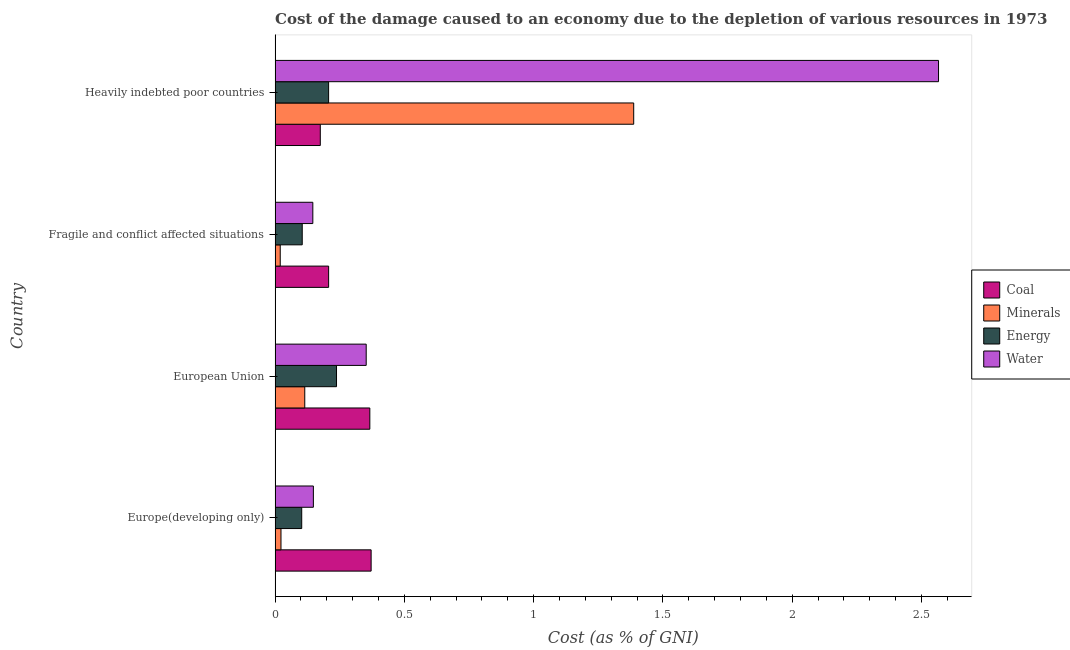How many bars are there on the 2nd tick from the top?
Keep it short and to the point. 4. How many bars are there on the 2nd tick from the bottom?
Your response must be concise. 4. What is the cost of damage due to depletion of energy in Fragile and conflict affected situations?
Provide a short and direct response. 0.11. Across all countries, what is the maximum cost of damage due to depletion of water?
Ensure brevity in your answer.  2.57. Across all countries, what is the minimum cost of damage due to depletion of energy?
Keep it short and to the point. 0.1. In which country was the cost of damage due to depletion of coal maximum?
Ensure brevity in your answer.  Europe(developing only). In which country was the cost of damage due to depletion of coal minimum?
Your answer should be very brief. Heavily indebted poor countries. What is the total cost of damage due to depletion of coal in the graph?
Offer a very short reply. 1.12. What is the difference between the cost of damage due to depletion of minerals in Europe(developing only) and that in Heavily indebted poor countries?
Offer a terse response. -1.36. What is the difference between the cost of damage due to depletion of water in Fragile and conflict affected situations and the cost of damage due to depletion of coal in European Union?
Keep it short and to the point. -0.22. What is the average cost of damage due to depletion of energy per country?
Offer a terse response. 0.16. What is the difference between the cost of damage due to depletion of coal and cost of damage due to depletion of minerals in Fragile and conflict affected situations?
Your answer should be very brief. 0.19. What is the ratio of the cost of damage due to depletion of energy in Fragile and conflict affected situations to that in Heavily indebted poor countries?
Your answer should be compact. 0.51. Is the cost of damage due to depletion of energy in Europe(developing only) less than that in Heavily indebted poor countries?
Your answer should be very brief. Yes. What is the difference between the highest and the second highest cost of damage due to depletion of water?
Offer a very short reply. 2.21. What is the difference between the highest and the lowest cost of damage due to depletion of coal?
Your response must be concise. 0.2. In how many countries, is the cost of damage due to depletion of energy greater than the average cost of damage due to depletion of energy taken over all countries?
Your answer should be compact. 2. Is the sum of the cost of damage due to depletion of minerals in European Union and Fragile and conflict affected situations greater than the maximum cost of damage due to depletion of water across all countries?
Your answer should be compact. No. What does the 1st bar from the top in European Union represents?
Offer a terse response. Water. What does the 2nd bar from the bottom in Europe(developing only) represents?
Offer a terse response. Minerals. Is it the case that in every country, the sum of the cost of damage due to depletion of coal and cost of damage due to depletion of minerals is greater than the cost of damage due to depletion of energy?
Make the answer very short. Yes. How many bars are there?
Ensure brevity in your answer.  16. How many countries are there in the graph?
Offer a terse response. 4. What is the difference between two consecutive major ticks on the X-axis?
Offer a terse response. 0.5. Are the values on the major ticks of X-axis written in scientific E-notation?
Your answer should be compact. No. Where does the legend appear in the graph?
Give a very brief answer. Center right. How are the legend labels stacked?
Your answer should be very brief. Vertical. What is the title of the graph?
Offer a very short reply. Cost of the damage caused to an economy due to the depletion of various resources in 1973 . What is the label or title of the X-axis?
Make the answer very short. Cost (as % of GNI). What is the Cost (as % of GNI) of Coal in Europe(developing only)?
Offer a terse response. 0.37. What is the Cost (as % of GNI) of Minerals in Europe(developing only)?
Your response must be concise. 0.02. What is the Cost (as % of GNI) of Energy in Europe(developing only)?
Your response must be concise. 0.1. What is the Cost (as % of GNI) in Water in Europe(developing only)?
Provide a succinct answer. 0.15. What is the Cost (as % of GNI) of Coal in European Union?
Make the answer very short. 0.37. What is the Cost (as % of GNI) of Minerals in European Union?
Keep it short and to the point. 0.11. What is the Cost (as % of GNI) in Energy in European Union?
Your answer should be compact. 0.24. What is the Cost (as % of GNI) in Water in European Union?
Offer a terse response. 0.35. What is the Cost (as % of GNI) in Coal in Fragile and conflict affected situations?
Offer a very short reply. 0.21. What is the Cost (as % of GNI) in Minerals in Fragile and conflict affected situations?
Provide a succinct answer. 0.02. What is the Cost (as % of GNI) of Energy in Fragile and conflict affected situations?
Give a very brief answer. 0.11. What is the Cost (as % of GNI) in Water in Fragile and conflict affected situations?
Your answer should be compact. 0.15. What is the Cost (as % of GNI) in Coal in Heavily indebted poor countries?
Provide a short and direct response. 0.17. What is the Cost (as % of GNI) of Minerals in Heavily indebted poor countries?
Provide a short and direct response. 1.39. What is the Cost (as % of GNI) of Energy in Heavily indebted poor countries?
Ensure brevity in your answer.  0.21. What is the Cost (as % of GNI) in Water in Heavily indebted poor countries?
Offer a terse response. 2.57. Across all countries, what is the maximum Cost (as % of GNI) in Coal?
Offer a terse response. 0.37. Across all countries, what is the maximum Cost (as % of GNI) in Minerals?
Your answer should be very brief. 1.39. Across all countries, what is the maximum Cost (as % of GNI) of Energy?
Keep it short and to the point. 0.24. Across all countries, what is the maximum Cost (as % of GNI) in Water?
Offer a terse response. 2.57. Across all countries, what is the minimum Cost (as % of GNI) in Coal?
Offer a terse response. 0.17. Across all countries, what is the minimum Cost (as % of GNI) in Minerals?
Your answer should be compact. 0.02. Across all countries, what is the minimum Cost (as % of GNI) of Energy?
Give a very brief answer. 0.1. Across all countries, what is the minimum Cost (as % of GNI) in Water?
Make the answer very short. 0.15. What is the total Cost (as % of GNI) in Coal in the graph?
Keep it short and to the point. 1.12. What is the total Cost (as % of GNI) of Minerals in the graph?
Your answer should be compact. 1.54. What is the total Cost (as % of GNI) of Energy in the graph?
Give a very brief answer. 0.65. What is the total Cost (as % of GNI) in Water in the graph?
Your response must be concise. 3.21. What is the difference between the Cost (as % of GNI) of Coal in Europe(developing only) and that in European Union?
Your response must be concise. 0.01. What is the difference between the Cost (as % of GNI) of Minerals in Europe(developing only) and that in European Union?
Offer a very short reply. -0.09. What is the difference between the Cost (as % of GNI) of Energy in Europe(developing only) and that in European Union?
Your answer should be very brief. -0.13. What is the difference between the Cost (as % of GNI) of Water in Europe(developing only) and that in European Union?
Your answer should be compact. -0.2. What is the difference between the Cost (as % of GNI) in Coal in Europe(developing only) and that in Fragile and conflict affected situations?
Offer a very short reply. 0.16. What is the difference between the Cost (as % of GNI) in Minerals in Europe(developing only) and that in Fragile and conflict affected situations?
Ensure brevity in your answer.  0. What is the difference between the Cost (as % of GNI) in Energy in Europe(developing only) and that in Fragile and conflict affected situations?
Provide a succinct answer. -0. What is the difference between the Cost (as % of GNI) of Water in Europe(developing only) and that in Fragile and conflict affected situations?
Offer a very short reply. 0. What is the difference between the Cost (as % of GNI) of Coal in Europe(developing only) and that in Heavily indebted poor countries?
Offer a very short reply. 0.2. What is the difference between the Cost (as % of GNI) in Minerals in Europe(developing only) and that in Heavily indebted poor countries?
Your answer should be compact. -1.36. What is the difference between the Cost (as % of GNI) of Energy in Europe(developing only) and that in Heavily indebted poor countries?
Make the answer very short. -0.1. What is the difference between the Cost (as % of GNI) in Water in Europe(developing only) and that in Heavily indebted poor countries?
Provide a short and direct response. -2.42. What is the difference between the Cost (as % of GNI) in Coal in European Union and that in Fragile and conflict affected situations?
Offer a very short reply. 0.16. What is the difference between the Cost (as % of GNI) in Minerals in European Union and that in Fragile and conflict affected situations?
Provide a short and direct response. 0.09. What is the difference between the Cost (as % of GNI) of Energy in European Union and that in Fragile and conflict affected situations?
Keep it short and to the point. 0.13. What is the difference between the Cost (as % of GNI) in Water in European Union and that in Fragile and conflict affected situations?
Ensure brevity in your answer.  0.21. What is the difference between the Cost (as % of GNI) of Coal in European Union and that in Heavily indebted poor countries?
Make the answer very short. 0.19. What is the difference between the Cost (as % of GNI) in Minerals in European Union and that in Heavily indebted poor countries?
Your response must be concise. -1.27. What is the difference between the Cost (as % of GNI) in Energy in European Union and that in Heavily indebted poor countries?
Your response must be concise. 0.03. What is the difference between the Cost (as % of GNI) in Water in European Union and that in Heavily indebted poor countries?
Offer a very short reply. -2.21. What is the difference between the Cost (as % of GNI) in Coal in Fragile and conflict affected situations and that in Heavily indebted poor countries?
Offer a very short reply. 0.03. What is the difference between the Cost (as % of GNI) in Minerals in Fragile and conflict affected situations and that in Heavily indebted poor countries?
Offer a very short reply. -1.37. What is the difference between the Cost (as % of GNI) of Energy in Fragile and conflict affected situations and that in Heavily indebted poor countries?
Make the answer very short. -0.1. What is the difference between the Cost (as % of GNI) in Water in Fragile and conflict affected situations and that in Heavily indebted poor countries?
Ensure brevity in your answer.  -2.42. What is the difference between the Cost (as % of GNI) of Coal in Europe(developing only) and the Cost (as % of GNI) of Minerals in European Union?
Your answer should be compact. 0.26. What is the difference between the Cost (as % of GNI) of Coal in Europe(developing only) and the Cost (as % of GNI) of Energy in European Union?
Your response must be concise. 0.13. What is the difference between the Cost (as % of GNI) of Coal in Europe(developing only) and the Cost (as % of GNI) of Water in European Union?
Keep it short and to the point. 0.02. What is the difference between the Cost (as % of GNI) in Minerals in Europe(developing only) and the Cost (as % of GNI) in Energy in European Union?
Keep it short and to the point. -0.21. What is the difference between the Cost (as % of GNI) of Minerals in Europe(developing only) and the Cost (as % of GNI) of Water in European Union?
Offer a terse response. -0.33. What is the difference between the Cost (as % of GNI) in Energy in Europe(developing only) and the Cost (as % of GNI) in Water in European Union?
Provide a succinct answer. -0.25. What is the difference between the Cost (as % of GNI) in Coal in Europe(developing only) and the Cost (as % of GNI) in Minerals in Fragile and conflict affected situations?
Provide a succinct answer. 0.35. What is the difference between the Cost (as % of GNI) in Coal in Europe(developing only) and the Cost (as % of GNI) in Energy in Fragile and conflict affected situations?
Make the answer very short. 0.27. What is the difference between the Cost (as % of GNI) in Coal in Europe(developing only) and the Cost (as % of GNI) in Water in Fragile and conflict affected situations?
Keep it short and to the point. 0.23. What is the difference between the Cost (as % of GNI) of Minerals in Europe(developing only) and the Cost (as % of GNI) of Energy in Fragile and conflict affected situations?
Your answer should be very brief. -0.08. What is the difference between the Cost (as % of GNI) of Minerals in Europe(developing only) and the Cost (as % of GNI) of Water in Fragile and conflict affected situations?
Give a very brief answer. -0.12. What is the difference between the Cost (as % of GNI) in Energy in Europe(developing only) and the Cost (as % of GNI) in Water in Fragile and conflict affected situations?
Keep it short and to the point. -0.04. What is the difference between the Cost (as % of GNI) in Coal in Europe(developing only) and the Cost (as % of GNI) in Minerals in Heavily indebted poor countries?
Your answer should be compact. -1.02. What is the difference between the Cost (as % of GNI) in Coal in Europe(developing only) and the Cost (as % of GNI) in Energy in Heavily indebted poor countries?
Make the answer very short. 0.16. What is the difference between the Cost (as % of GNI) of Coal in Europe(developing only) and the Cost (as % of GNI) of Water in Heavily indebted poor countries?
Make the answer very short. -2.19. What is the difference between the Cost (as % of GNI) of Minerals in Europe(developing only) and the Cost (as % of GNI) of Energy in Heavily indebted poor countries?
Your answer should be compact. -0.18. What is the difference between the Cost (as % of GNI) of Minerals in Europe(developing only) and the Cost (as % of GNI) of Water in Heavily indebted poor countries?
Provide a short and direct response. -2.54. What is the difference between the Cost (as % of GNI) of Energy in Europe(developing only) and the Cost (as % of GNI) of Water in Heavily indebted poor countries?
Give a very brief answer. -2.46. What is the difference between the Cost (as % of GNI) of Coal in European Union and the Cost (as % of GNI) of Minerals in Fragile and conflict affected situations?
Your answer should be very brief. 0.35. What is the difference between the Cost (as % of GNI) of Coal in European Union and the Cost (as % of GNI) of Energy in Fragile and conflict affected situations?
Provide a short and direct response. 0.26. What is the difference between the Cost (as % of GNI) in Coal in European Union and the Cost (as % of GNI) in Water in Fragile and conflict affected situations?
Offer a terse response. 0.22. What is the difference between the Cost (as % of GNI) of Minerals in European Union and the Cost (as % of GNI) of Energy in Fragile and conflict affected situations?
Provide a succinct answer. 0.01. What is the difference between the Cost (as % of GNI) of Minerals in European Union and the Cost (as % of GNI) of Water in Fragile and conflict affected situations?
Keep it short and to the point. -0.03. What is the difference between the Cost (as % of GNI) of Energy in European Union and the Cost (as % of GNI) of Water in Fragile and conflict affected situations?
Your response must be concise. 0.09. What is the difference between the Cost (as % of GNI) in Coal in European Union and the Cost (as % of GNI) in Minerals in Heavily indebted poor countries?
Your response must be concise. -1.02. What is the difference between the Cost (as % of GNI) of Coal in European Union and the Cost (as % of GNI) of Energy in Heavily indebted poor countries?
Your answer should be very brief. 0.16. What is the difference between the Cost (as % of GNI) in Coal in European Union and the Cost (as % of GNI) in Water in Heavily indebted poor countries?
Offer a very short reply. -2.2. What is the difference between the Cost (as % of GNI) in Minerals in European Union and the Cost (as % of GNI) in Energy in Heavily indebted poor countries?
Offer a very short reply. -0.09. What is the difference between the Cost (as % of GNI) of Minerals in European Union and the Cost (as % of GNI) of Water in Heavily indebted poor countries?
Offer a very short reply. -2.45. What is the difference between the Cost (as % of GNI) in Energy in European Union and the Cost (as % of GNI) in Water in Heavily indebted poor countries?
Provide a short and direct response. -2.33. What is the difference between the Cost (as % of GNI) in Coal in Fragile and conflict affected situations and the Cost (as % of GNI) in Minerals in Heavily indebted poor countries?
Keep it short and to the point. -1.18. What is the difference between the Cost (as % of GNI) in Coal in Fragile and conflict affected situations and the Cost (as % of GNI) in Energy in Heavily indebted poor countries?
Make the answer very short. 0. What is the difference between the Cost (as % of GNI) in Coal in Fragile and conflict affected situations and the Cost (as % of GNI) in Water in Heavily indebted poor countries?
Offer a very short reply. -2.36. What is the difference between the Cost (as % of GNI) in Minerals in Fragile and conflict affected situations and the Cost (as % of GNI) in Energy in Heavily indebted poor countries?
Ensure brevity in your answer.  -0.19. What is the difference between the Cost (as % of GNI) in Minerals in Fragile and conflict affected situations and the Cost (as % of GNI) in Water in Heavily indebted poor countries?
Your answer should be compact. -2.55. What is the difference between the Cost (as % of GNI) in Energy in Fragile and conflict affected situations and the Cost (as % of GNI) in Water in Heavily indebted poor countries?
Keep it short and to the point. -2.46. What is the average Cost (as % of GNI) in Coal per country?
Your response must be concise. 0.28. What is the average Cost (as % of GNI) of Minerals per country?
Your response must be concise. 0.39. What is the average Cost (as % of GNI) in Energy per country?
Offer a terse response. 0.16. What is the average Cost (as % of GNI) of Water per country?
Your answer should be very brief. 0.8. What is the difference between the Cost (as % of GNI) of Coal and Cost (as % of GNI) of Minerals in Europe(developing only)?
Keep it short and to the point. 0.35. What is the difference between the Cost (as % of GNI) of Coal and Cost (as % of GNI) of Energy in Europe(developing only)?
Offer a terse response. 0.27. What is the difference between the Cost (as % of GNI) in Coal and Cost (as % of GNI) in Water in Europe(developing only)?
Make the answer very short. 0.22. What is the difference between the Cost (as % of GNI) of Minerals and Cost (as % of GNI) of Energy in Europe(developing only)?
Provide a short and direct response. -0.08. What is the difference between the Cost (as % of GNI) of Minerals and Cost (as % of GNI) of Water in Europe(developing only)?
Your response must be concise. -0.13. What is the difference between the Cost (as % of GNI) of Energy and Cost (as % of GNI) of Water in Europe(developing only)?
Offer a very short reply. -0.05. What is the difference between the Cost (as % of GNI) in Coal and Cost (as % of GNI) in Minerals in European Union?
Provide a short and direct response. 0.25. What is the difference between the Cost (as % of GNI) of Coal and Cost (as % of GNI) of Energy in European Union?
Offer a terse response. 0.13. What is the difference between the Cost (as % of GNI) of Coal and Cost (as % of GNI) of Water in European Union?
Your answer should be compact. 0.01. What is the difference between the Cost (as % of GNI) in Minerals and Cost (as % of GNI) in Energy in European Union?
Make the answer very short. -0.12. What is the difference between the Cost (as % of GNI) of Minerals and Cost (as % of GNI) of Water in European Union?
Ensure brevity in your answer.  -0.24. What is the difference between the Cost (as % of GNI) in Energy and Cost (as % of GNI) in Water in European Union?
Offer a terse response. -0.11. What is the difference between the Cost (as % of GNI) in Coal and Cost (as % of GNI) in Minerals in Fragile and conflict affected situations?
Ensure brevity in your answer.  0.19. What is the difference between the Cost (as % of GNI) in Coal and Cost (as % of GNI) in Energy in Fragile and conflict affected situations?
Your response must be concise. 0.1. What is the difference between the Cost (as % of GNI) of Coal and Cost (as % of GNI) of Water in Fragile and conflict affected situations?
Keep it short and to the point. 0.06. What is the difference between the Cost (as % of GNI) in Minerals and Cost (as % of GNI) in Energy in Fragile and conflict affected situations?
Provide a succinct answer. -0.09. What is the difference between the Cost (as % of GNI) of Minerals and Cost (as % of GNI) of Water in Fragile and conflict affected situations?
Your response must be concise. -0.13. What is the difference between the Cost (as % of GNI) of Energy and Cost (as % of GNI) of Water in Fragile and conflict affected situations?
Provide a short and direct response. -0.04. What is the difference between the Cost (as % of GNI) of Coal and Cost (as % of GNI) of Minerals in Heavily indebted poor countries?
Your answer should be compact. -1.21. What is the difference between the Cost (as % of GNI) in Coal and Cost (as % of GNI) in Energy in Heavily indebted poor countries?
Your answer should be very brief. -0.03. What is the difference between the Cost (as % of GNI) in Coal and Cost (as % of GNI) in Water in Heavily indebted poor countries?
Your answer should be compact. -2.39. What is the difference between the Cost (as % of GNI) in Minerals and Cost (as % of GNI) in Energy in Heavily indebted poor countries?
Keep it short and to the point. 1.18. What is the difference between the Cost (as % of GNI) in Minerals and Cost (as % of GNI) in Water in Heavily indebted poor countries?
Keep it short and to the point. -1.18. What is the difference between the Cost (as % of GNI) in Energy and Cost (as % of GNI) in Water in Heavily indebted poor countries?
Your response must be concise. -2.36. What is the ratio of the Cost (as % of GNI) of Coal in Europe(developing only) to that in European Union?
Offer a terse response. 1.01. What is the ratio of the Cost (as % of GNI) of Minerals in Europe(developing only) to that in European Union?
Your response must be concise. 0.2. What is the ratio of the Cost (as % of GNI) in Energy in Europe(developing only) to that in European Union?
Keep it short and to the point. 0.43. What is the ratio of the Cost (as % of GNI) of Water in Europe(developing only) to that in European Union?
Provide a succinct answer. 0.42. What is the ratio of the Cost (as % of GNI) in Coal in Europe(developing only) to that in Fragile and conflict affected situations?
Keep it short and to the point. 1.79. What is the ratio of the Cost (as % of GNI) of Minerals in Europe(developing only) to that in Fragile and conflict affected situations?
Offer a very short reply. 1.14. What is the ratio of the Cost (as % of GNI) in Water in Europe(developing only) to that in Fragile and conflict affected situations?
Offer a very short reply. 1.01. What is the ratio of the Cost (as % of GNI) of Coal in Europe(developing only) to that in Heavily indebted poor countries?
Keep it short and to the point. 2.12. What is the ratio of the Cost (as % of GNI) of Minerals in Europe(developing only) to that in Heavily indebted poor countries?
Your response must be concise. 0.02. What is the ratio of the Cost (as % of GNI) of Energy in Europe(developing only) to that in Heavily indebted poor countries?
Ensure brevity in your answer.  0.5. What is the ratio of the Cost (as % of GNI) in Water in Europe(developing only) to that in Heavily indebted poor countries?
Give a very brief answer. 0.06. What is the ratio of the Cost (as % of GNI) of Coal in European Union to that in Fragile and conflict affected situations?
Offer a very short reply. 1.77. What is the ratio of the Cost (as % of GNI) in Minerals in European Union to that in Fragile and conflict affected situations?
Provide a short and direct response. 5.75. What is the ratio of the Cost (as % of GNI) in Energy in European Union to that in Fragile and conflict affected situations?
Keep it short and to the point. 2.26. What is the ratio of the Cost (as % of GNI) in Water in European Union to that in Fragile and conflict affected situations?
Provide a succinct answer. 2.41. What is the ratio of the Cost (as % of GNI) in Coal in European Union to that in Heavily indebted poor countries?
Ensure brevity in your answer.  2.1. What is the ratio of the Cost (as % of GNI) in Minerals in European Union to that in Heavily indebted poor countries?
Give a very brief answer. 0.08. What is the ratio of the Cost (as % of GNI) of Energy in European Union to that in Heavily indebted poor countries?
Your answer should be compact. 1.15. What is the ratio of the Cost (as % of GNI) of Water in European Union to that in Heavily indebted poor countries?
Ensure brevity in your answer.  0.14. What is the ratio of the Cost (as % of GNI) of Coal in Fragile and conflict affected situations to that in Heavily indebted poor countries?
Your answer should be compact. 1.18. What is the ratio of the Cost (as % of GNI) in Minerals in Fragile and conflict affected situations to that in Heavily indebted poor countries?
Make the answer very short. 0.01. What is the ratio of the Cost (as % of GNI) of Energy in Fragile and conflict affected situations to that in Heavily indebted poor countries?
Give a very brief answer. 0.51. What is the ratio of the Cost (as % of GNI) in Water in Fragile and conflict affected situations to that in Heavily indebted poor countries?
Give a very brief answer. 0.06. What is the difference between the highest and the second highest Cost (as % of GNI) in Coal?
Offer a terse response. 0.01. What is the difference between the highest and the second highest Cost (as % of GNI) in Minerals?
Your response must be concise. 1.27. What is the difference between the highest and the second highest Cost (as % of GNI) in Energy?
Make the answer very short. 0.03. What is the difference between the highest and the second highest Cost (as % of GNI) of Water?
Give a very brief answer. 2.21. What is the difference between the highest and the lowest Cost (as % of GNI) in Coal?
Offer a very short reply. 0.2. What is the difference between the highest and the lowest Cost (as % of GNI) of Minerals?
Make the answer very short. 1.37. What is the difference between the highest and the lowest Cost (as % of GNI) in Energy?
Offer a terse response. 0.13. What is the difference between the highest and the lowest Cost (as % of GNI) in Water?
Your answer should be compact. 2.42. 